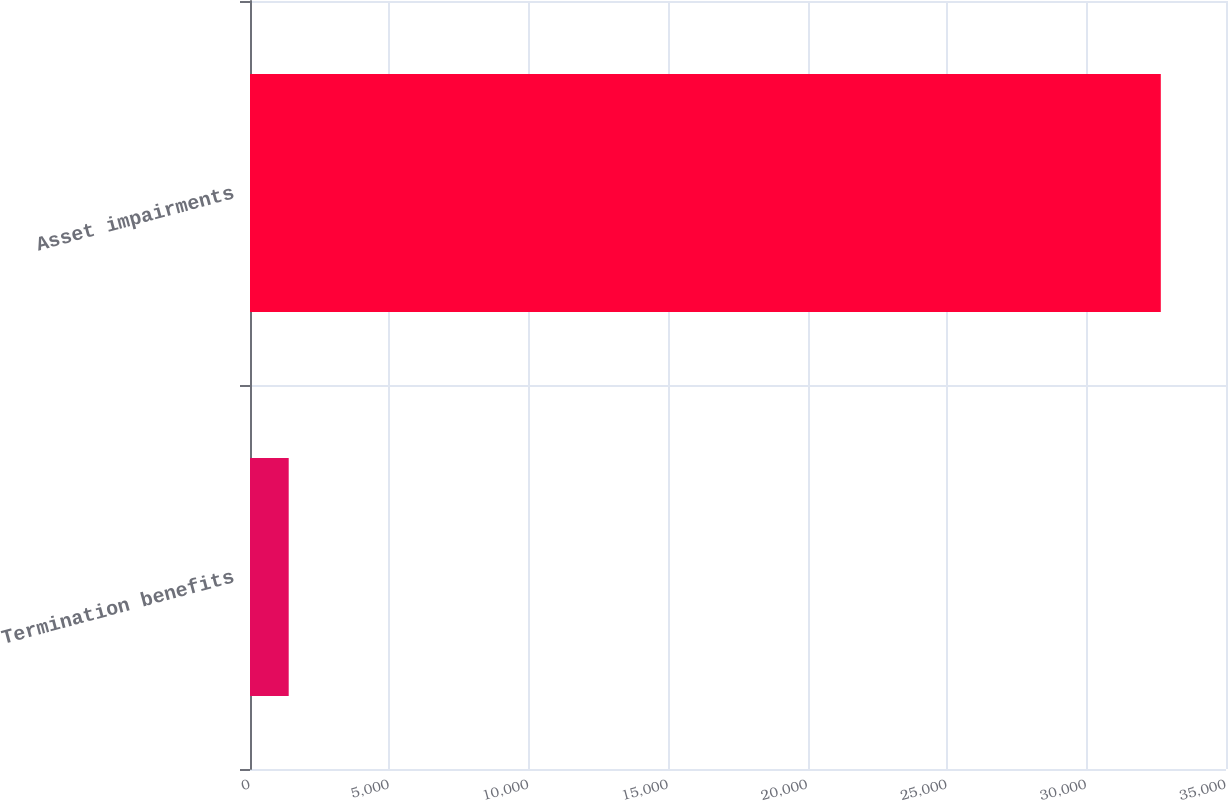Convert chart. <chart><loc_0><loc_0><loc_500><loc_500><bar_chart><fcel>Termination benefits<fcel>Asset impairments<nl><fcel>1388<fcel>32662<nl></chart> 